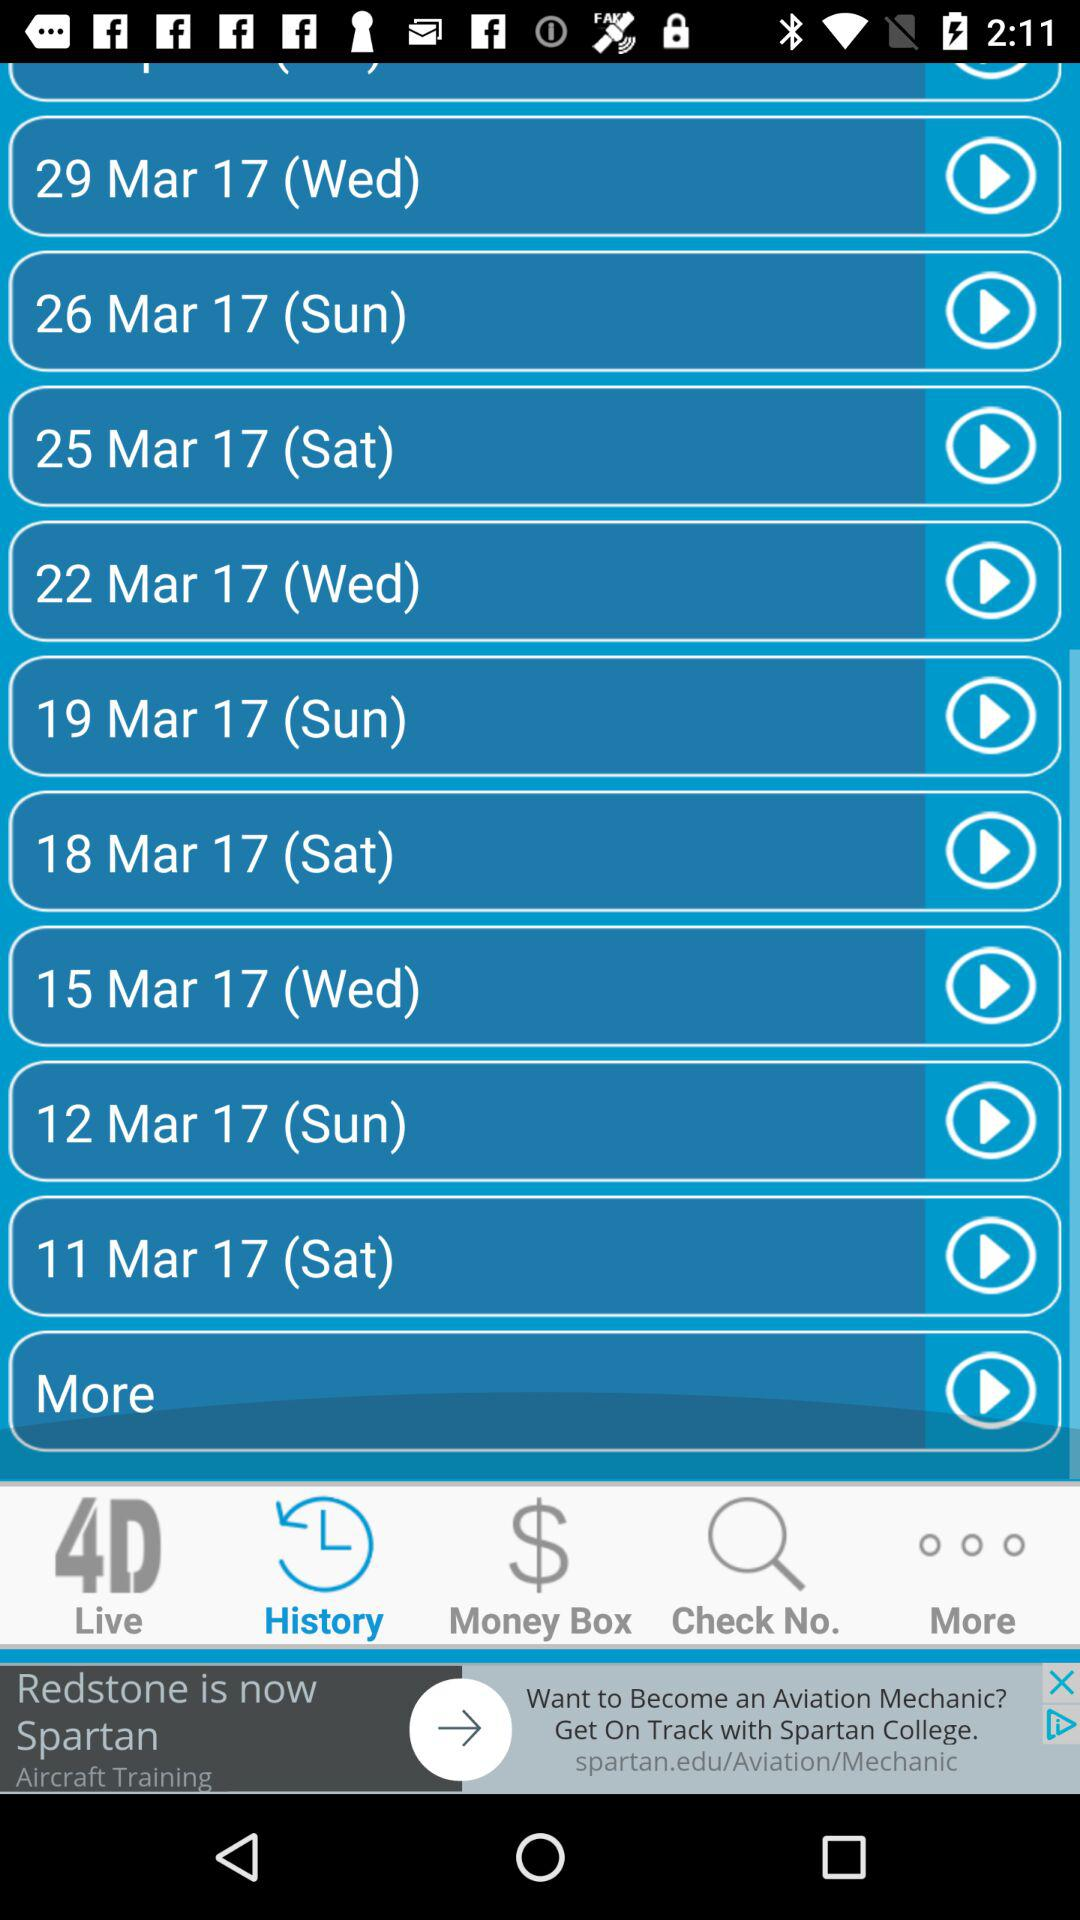How many notifications are there in "Money Box"?
When the provided information is insufficient, respond with <no answer>. <no answer> 